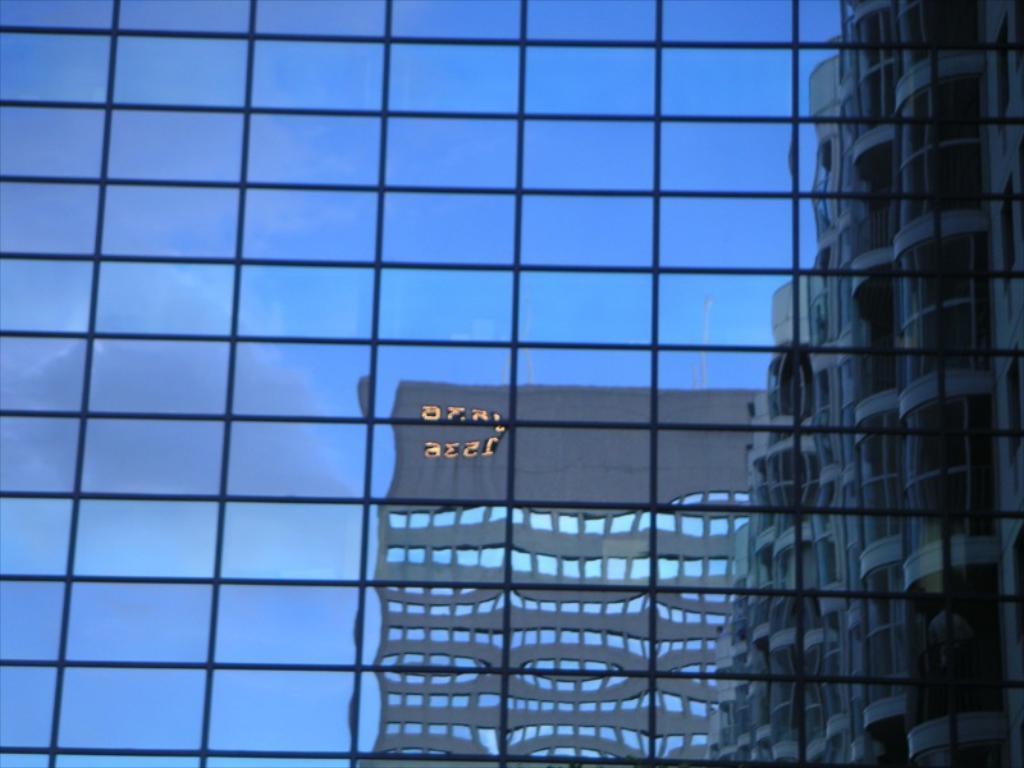Describe this image in one or two sentences. In this image in front there is a glass window. Through glass window we can see buildings and sky. 